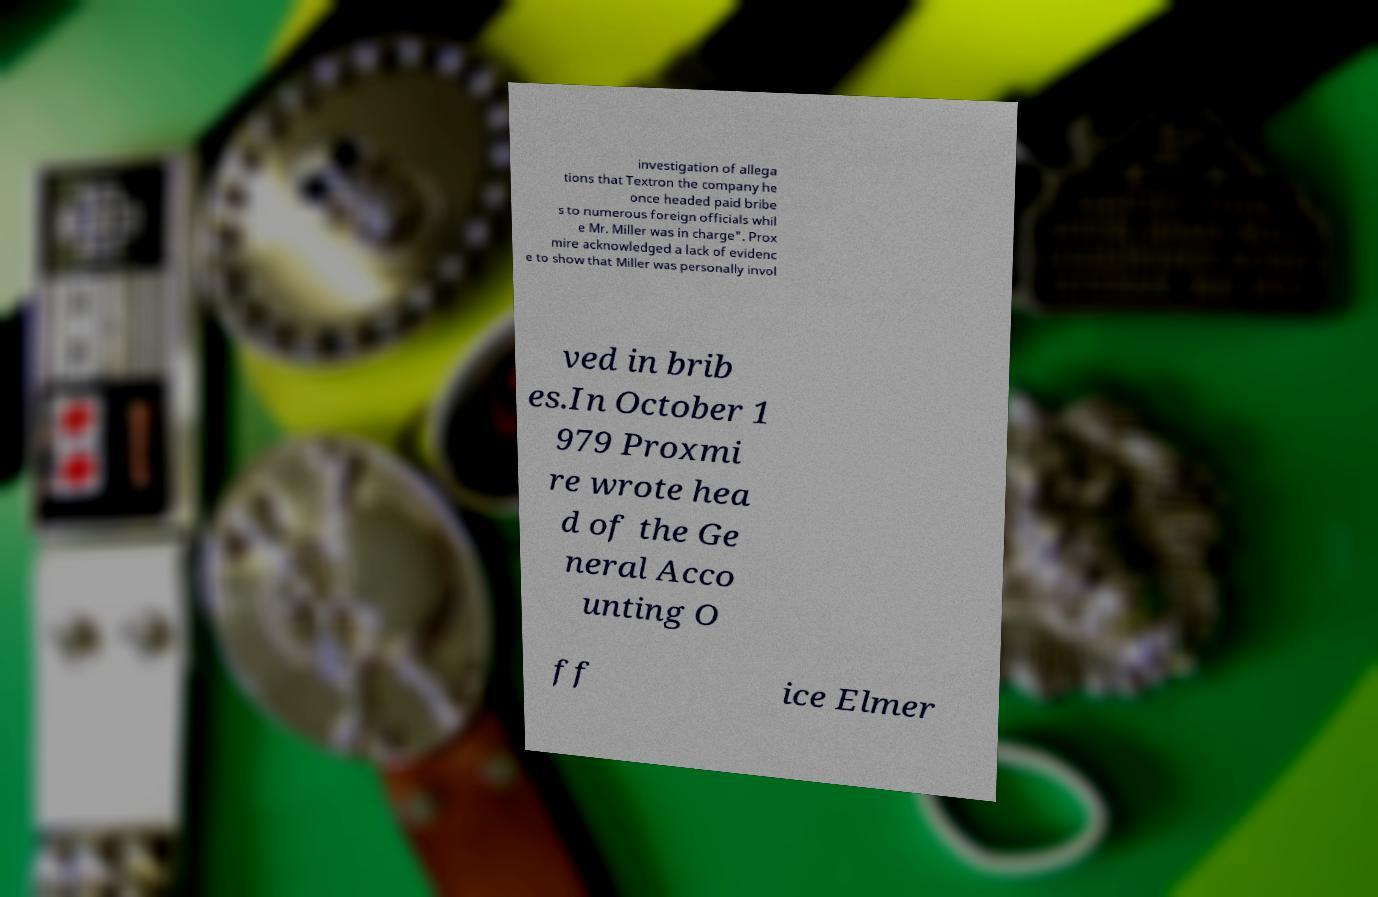Could you assist in decoding the text presented in this image and type it out clearly? investigation of allega tions that Textron the company he once headed paid bribe s to numerous foreign officials whil e Mr. Miller was in charge". Prox mire acknowledged a lack of evidenc e to show that Miller was personally invol ved in brib es.In October 1 979 Proxmi re wrote hea d of the Ge neral Acco unting O ff ice Elmer 